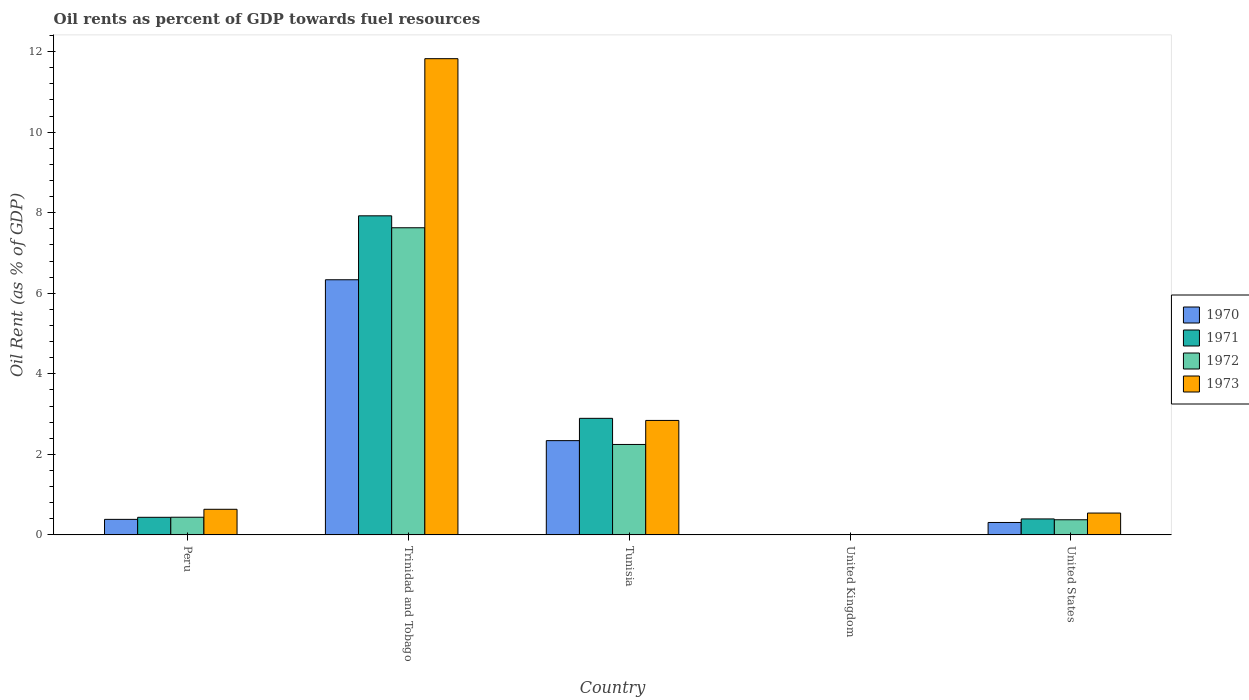Are the number of bars on each tick of the X-axis equal?
Keep it short and to the point. Yes. How many bars are there on the 5th tick from the left?
Your answer should be compact. 4. What is the label of the 5th group of bars from the left?
Give a very brief answer. United States. In how many cases, is the number of bars for a given country not equal to the number of legend labels?
Provide a succinct answer. 0. What is the oil rent in 1972 in Peru?
Provide a short and direct response. 0.44. Across all countries, what is the maximum oil rent in 1971?
Your answer should be compact. 7.92. Across all countries, what is the minimum oil rent in 1973?
Provide a short and direct response. 0. In which country was the oil rent in 1973 maximum?
Ensure brevity in your answer.  Trinidad and Tobago. In which country was the oil rent in 1972 minimum?
Make the answer very short. United Kingdom. What is the total oil rent in 1970 in the graph?
Offer a terse response. 9.37. What is the difference between the oil rent in 1970 in Peru and that in United Kingdom?
Provide a succinct answer. 0.38. What is the difference between the oil rent in 1972 in United Kingdom and the oil rent in 1973 in Peru?
Keep it short and to the point. -0.63. What is the average oil rent in 1970 per country?
Ensure brevity in your answer.  1.87. What is the difference between the oil rent of/in 1971 and oil rent of/in 1972 in United States?
Your response must be concise. 0.02. In how many countries, is the oil rent in 1970 greater than 6.8 %?
Ensure brevity in your answer.  0. What is the ratio of the oil rent in 1970 in Tunisia to that in United States?
Give a very brief answer. 7.59. Is the difference between the oil rent in 1971 in Trinidad and Tobago and Tunisia greater than the difference between the oil rent in 1972 in Trinidad and Tobago and Tunisia?
Ensure brevity in your answer.  No. What is the difference between the highest and the second highest oil rent in 1970?
Your answer should be compact. -1.95. What is the difference between the highest and the lowest oil rent in 1972?
Your response must be concise. 7.62. What does the 4th bar from the right in Trinidad and Tobago represents?
Give a very brief answer. 1970. How many bars are there?
Provide a succinct answer. 20. What is the difference between two consecutive major ticks on the Y-axis?
Your answer should be compact. 2. What is the title of the graph?
Give a very brief answer. Oil rents as percent of GDP towards fuel resources. What is the label or title of the X-axis?
Ensure brevity in your answer.  Country. What is the label or title of the Y-axis?
Your response must be concise. Oil Rent (as % of GDP). What is the Oil Rent (as % of GDP) of 1970 in Peru?
Offer a terse response. 0.39. What is the Oil Rent (as % of GDP) in 1971 in Peru?
Ensure brevity in your answer.  0.44. What is the Oil Rent (as % of GDP) in 1972 in Peru?
Keep it short and to the point. 0.44. What is the Oil Rent (as % of GDP) of 1973 in Peru?
Provide a short and direct response. 0.64. What is the Oil Rent (as % of GDP) of 1970 in Trinidad and Tobago?
Ensure brevity in your answer.  6.33. What is the Oil Rent (as % of GDP) in 1971 in Trinidad and Tobago?
Your response must be concise. 7.92. What is the Oil Rent (as % of GDP) of 1972 in Trinidad and Tobago?
Offer a terse response. 7.63. What is the Oil Rent (as % of GDP) of 1973 in Trinidad and Tobago?
Keep it short and to the point. 11.82. What is the Oil Rent (as % of GDP) in 1970 in Tunisia?
Provide a short and direct response. 2.34. What is the Oil Rent (as % of GDP) in 1971 in Tunisia?
Provide a succinct answer. 2.89. What is the Oil Rent (as % of GDP) in 1972 in Tunisia?
Give a very brief answer. 2.25. What is the Oil Rent (as % of GDP) in 1973 in Tunisia?
Keep it short and to the point. 2.84. What is the Oil Rent (as % of GDP) of 1970 in United Kingdom?
Offer a terse response. 0. What is the Oil Rent (as % of GDP) in 1971 in United Kingdom?
Your answer should be compact. 0. What is the Oil Rent (as % of GDP) of 1972 in United Kingdom?
Your response must be concise. 0. What is the Oil Rent (as % of GDP) in 1973 in United Kingdom?
Offer a terse response. 0. What is the Oil Rent (as % of GDP) of 1970 in United States?
Your answer should be compact. 0.31. What is the Oil Rent (as % of GDP) in 1971 in United States?
Your answer should be compact. 0.4. What is the Oil Rent (as % of GDP) in 1972 in United States?
Your answer should be compact. 0.38. What is the Oil Rent (as % of GDP) of 1973 in United States?
Give a very brief answer. 0.54. Across all countries, what is the maximum Oil Rent (as % of GDP) in 1970?
Your answer should be compact. 6.33. Across all countries, what is the maximum Oil Rent (as % of GDP) of 1971?
Offer a terse response. 7.92. Across all countries, what is the maximum Oil Rent (as % of GDP) in 1972?
Keep it short and to the point. 7.63. Across all countries, what is the maximum Oil Rent (as % of GDP) in 1973?
Make the answer very short. 11.82. Across all countries, what is the minimum Oil Rent (as % of GDP) in 1970?
Make the answer very short. 0. Across all countries, what is the minimum Oil Rent (as % of GDP) in 1971?
Offer a very short reply. 0. Across all countries, what is the minimum Oil Rent (as % of GDP) in 1972?
Your answer should be compact. 0. Across all countries, what is the minimum Oil Rent (as % of GDP) in 1973?
Provide a short and direct response. 0. What is the total Oil Rent (as % of GDP) in 1970 in the graph?
Make the answer very short. 9.37. What is the total Oil Rent (as % of GDP) in 1971 in the graph?
Offer a very short reply. 11.65. What is the total Oil Rent (as % of GDP) of 1972 in the graph?
Offer a very short reply. 10.69. What is the total Oil Rent (as % of GDP) of 1973 in the graph?
Offer a terse response. 15.85. What is the difference between the Oil Rent (as % of GDP) of 1970 in Peru and that in Trinidad and Tobago?
Your response must be concise. -5.95. What is the difference between the Oil Rent (as % of GDP) of 1971 in Peru and that in Trinidad and Tobago?
Your response must be concise. -7.49. What is the difference between the Oil Rent (as % of GDP) in 1972 in Peru and that in Trinidad and Tobago?
Your answer should be very brief. -7.19. What is the difference between the Oil Rent (as % of GDP) of 1973 in Peru and that in Trinidad and Tobago?
Ensure brevity in your answer.  -11.19. What is the difference between the Oil Rent (as % of GDP) in 1970 in Peru and that in Tunisia?
Ensure brevity in your answer.  -1.95. What is the difference between the Oil Rent (as % of GDP) in 1971 in Peru and that in Tunisia?
Keep it short and to the point. -2.46. What is the difference between the Oil Rent (as % of GDP) in 1972 in Peru and that in Tunisia?
Give a very brief answer. -1.81. What is the difference between the Oil Rent (as % of GDP) of 1973 in Peru and that in Tunisia?
Offer a very short reply. -2.21. What is the difference between the Oil Rent (as % of GDP) of 1970 in Peru and that in United Kingdom?
Provide a short and direct response. 0.38. What is the difference between the Oil Rent (as % of GDP) of 1971 in Peru and that in United Kingdom?
Offer a terse response. 0.44. What is the difference between the Oil Rent (as % of GDP) of 1972 in Peru and that in United Kingdom?
Ensure brevity in your answer.  0.44. What is the difference between the Oil Rent (as % of GDP) of 1973 in Peru and that in United Kingdom?
Make the answer very short. 0.63. What is the difference between the Oil Rent (as % of GDP) in 1970 in Peru and that in United States?
Your answer should be very brief. 0.08. What is the difference between the Oil Rent (as % of GDP) in 1971 in Peru and that in United States?
Ensure brevity in your answer.  0.04. What is the difference between the Oil Rent (as % of GDP) of 1972 in Peru and that in United States?
Offer a terse response. 0.06. What is the difference between the Oil Rent (as % of GDP) in 1973 in Peru and that in United States?
Provide a succinct answer. 0.09. What is the difference between the Oil Rent (as % of GDP) in 1970 in Trinidad and Tobago and that in Tunisia?
Provide a succinct answer. 3.99. What is the difference between the Oil Rent (as % of GDP) in 1971 in Trinidad and Tobago and that in Tunisia?
Ensure brevity in your answer.  5.03. What is the difference between the Oil Rent (as % of GDP) in 1972 in Trinidad and Tobago and that in Tunisia?
Your response must be concise. 5.38. What is the difference between the Oil Rent (as % of GDP) in 1973 in Trinidad and Tobago and that in Tunisia?
Make the answer very short. 8.98. What is the difference between the Oil Rent (as % of GDP) of 1970 in Trinidad and Tobago and that in United Kingdom?
Your answer should be compact. 6.33. What is the difference between the Oil Rent (as % of GDP) of 1971 in Trinidad and Tobago and that in United Kingdom?
Provide a short and direct response. 7.92. What is the difference between the Oil Rent (as % of GDP) in 1972 in Trinidad and Tobago and that in United Kingdom?
Your answer should be compact. 7.62. What is the difference between the Oil Rent (as % of GDP) in 1973 in Trinidad and Tobago and that in United Kingdom?
Offer a terse response. 11.82. What is the difference between the Oil Rent (as % of GDP) in 1970 in Trinidad and Tobago and that in United States?
Offer a terse response. 6.03. What is the difference between the Oil Rent (as % of GDP) in 1971 in Trinidad and Tobago and that in United States?
Provide a short and direct response. 7.53. What is the difference between the Oil Rent (as % of GDP) in 1972 in Trinidad and Tobago and that in United States?
Make the answer very short. 7.25. What is the difference between the Oil Rent (as % of GDP) in 1973 in Trinidad and Tobago and that in United States?
Provide a short and direct response. 11.28. What is the difference between the Oil Rent (as % of GDP) in 1970 in Tunisia and that in United Kingdom?
Your answer should be very brief. 2.34. What is the difference between the Oil Rent (as % of GDP) in 1971 in Tunisia and that in United Kingdom?
Keep it short and to the point. 2.89. What is the difference between the Oil Rent (as % of GDP) of 1972 in Tunisia and that in United Kingdom?
Provide a short and direct response. 2.24. What is the difference between the Oil Rent (as % of GDP) of 1973 in Tunisia and that in United Kingdom?
Your response must be concise. 2.84. What is the difference between the Oil Rent (as % of GDP) of 1970 in Tunisia and that in United States?
Your answer should be very brief. 2.03. What is the difference between the Oil Rent (as % of GDP) in 1971 in Tunisia and that in United States?
Provide a short and direct response. 2.5. What is the difference between the Oil Rent (as % of GDP) of 1972 in Tunisia and that in United States?
Offer a terse response. 1.87. What is the difference between the Oil Rent (as % of GDP) of 1973 in Tunisia and that in United States?
Your response must be concise. 2.3. What is the difference between the Oil Rent (as % of GDP) in 1970 in United Kingdom and that in United States?
Ensure brevity in your answer.  -0.31. What is the difference between the Oil Rent (as % of GDP) of 1971 in United Kingdom and that in United States?
Your answer should be compact. -0.4. What is the difference between the Oil Rent (as % of GDP) in 1972 in United Kingdom and that in United States?
Keep it short and to the point. -0.37. What is the difference between the Oil Rent (as % of GDP) in 1973 in United Kingdom and that in United States?
Provide a succinct answer. -0.54. What is the difference between the Oil Rent (as % of GDP) of 1970 in Peru and the Oil Rent (as % of GDP) of 1971 in Trinidad and Tobago?
Your answer should be compact. -7.54. What is the difference between the Oil Rent (as % of GDP) of 1970 in Peru and the Oil Rent (as % of GDP) of 1972 in Trinidad and Tobago?
Provide a short and direct response. -7.24. What is the difference between the Oil Rent (as % of GDP) in 1970 in Peru and the Oil Rent (as % of GDP) in 1973 in Trinidad and Tobago?
Offer a very short reply. -11.44. What is the difference between the Oil Rent (as % of GDP) of 1971 in Peru and the Oil Rent (as % of GDP) of 1972 in Trinidad and Tobago?
Offer a terse response. -7.19. What is the difference between the Oil Rent (as % of GDP) of 1971 in Peru and the Oil Rent (as % of GDP) of 1973 in Trinidad and Tobago?
Provide a short and direct response. -11.39. What is the difference between the Oil Rent (as % of GDP) in 1972 in Peru and the Oil Rent (as % of GDP) in 1973 in Trinidad and Tobago?
Provide a short and direct response. -11.38. What is the difference between the Oil Rent (as % of GDP) in 1970 in Peru and the Oil Rent (as % of GDP) in 1971 in Tunisia?
Your response must be concise. -2.51. What is the difference between the Oil Rent (as % of GDP) of 1970 in Peru and the Oil Rent (as % of GDP) of 1972 in Tunisia?
Keep it short and to the point. -1.86. What is the difference between the Oil Rent (as % of GDP) of 1970 in Peru and the Oil Rent (as % of GDP) of 1973 in Tunisia?
Offer a very short reply. -2.46. What is the difference between the Oil Rent (as % of GDP) of 1971 in Peru and the Oil Rent (as % of GDP) of 1972 in Tunisia?
Offer a very short reply. -1.81. What is the difference between the Oil Rent (as % of GDP) of 1971 in Peru and the Oil Rent (as % of GDP) of 1973 in Tunisia?
Offer a terse response. -2.4. What is the difference between the Oil Rent (as % of GDP) of 1972 in Peru and the Oil Rent (as % of GDP) of 1973 in Tunisia?
Your response must be concise. -2.4. What is the difference between the Oil Rent (as % of GDP) of 1970 in Peru and the Oil Rent (as % of GDP) of 1971 in United Kingdom?
Keep it short and to the point. 0.38. What is the difference between the Oil Rent (as % of GDP) in 1970 in Peru and the Oil Rent (as % of GDP) in 1972 in United Kingdom?
Your answer should be very brief. 0.38. What is the difference between the Oil Rent (as % of GDP) in 1970 in Peru and the Oil Rent (as % of GDP) in 1973 in United Kingdom?
Provide a succinct answer. 0.38. What is the difference between the Oil Rent (as % of GDP) in 1971 in Peru and the Oil Rent (as % of GDP) in 1972 in United Kingdom?
Your answer should be very brief. 0.44. What is the difference between the Oil Rent (as % of GDP) of 1971 in Peru and the Oil Rent (as % of GDP) of 1973 in United Kingdom?
Offer a very short reply. 0.43. What is the difference between the Oil Rent (as % of GDP) of 1972 in Peru and the Oil Rent (as % of GDP) of 1973 in United Kingdom?
Keep it short and to the point. 0.44. What is the difference between the Oil Rent (as % of GDP) of 1970 in Peru and the Oil Rent (as % of GDP) of 1971 in United States?
Make the answer very short. -0.01. What is the difference between the Oil Rent (as % of GDP) in 1970 in Peru and the Oil Rent (as % of GDP) in 1972 in United States?
Provide a short and direct response. 0.01. What is the difference between the Oil Rent (as % of GDP) in 1970 in Peru and the Oil Rent (as % of GDP) in 1973 in United States?
Offer a very short reply. -0.16. What is the difference between the Oil Rent (as % of GDP) in 1971 in Peru and the Oil Rent (as % of GDP) in 1972 in United States?
Provide a short and direct response. 0.06. What is the difference between the Oil Rent (as % of GDP) in 1971 in Peru and the Oil Rent (as % of GDP) in 1973 in United States?
Offer a very short reply. -0.11. What is the difference between the Oil Rent (as % of GDP) of 1972 in Peru and the Oil Rent (as % of GDP) of 1973 in United States?
Give a very brief answer. -0.1. What is the difference between the Oil Rent (as % of GDP) in 1970 in Trinidad and Tobago and the Oil Rent (as % of GDP) in 1971 in Tunisia?
Your answer should be compact. 3.44. What is the difference between the Oil Rent (as % of GDP) of 1970 in Trinidad and Tobago and the Oil Rent (as % of GDP) of 1972 in Tunisia?
Your response must be concise. 4.09. What is the difference between the Oil Rent (as % of GDP) in 1970 in Trinidad and Tobago and the Oil Rent (as % of GDP) in 1973 in Tunisia?
Your answer should be compact. 3.49. What is the difference between the Oil Rent (as % of GDP) of 1971 in Trinidad and Tobago and the Oil Rent (as % of GDP) of 1972 in Tunisia?
Give a very brief answer. 5.68. What is the difference between the Oil Rent (as % of GDP) of 1971 in Trinidad and Tobago and the Oil Rent (as % of GDP) of 1973 in Tunisia?
Provide a short and direct response. 5.08. What is the difference between the Oil Rent (as % of GDP) of 1972 in Trinidad and Tobago and the Oil Rent (as % of GDP) of 1973 in Tunisia?
Give a very brief answer. 4.78. What is the difference between the Oil Rent (as % of GDP) of 1970 in Trinidad and Tobago and the Oil Rent (as % of GDP) of 1971 in United Kingdom?
Your answer should be compact. 6.33. What is the difference between the Oil Rent (as % of GDP) in 1970 in Trinidad and Tobago and the Oil Rent (as % of GDP) in 1972 in United Kingdom?
Give a very brief answer. 6.33. What is the difference between the Oil Rent (as % of GDP) of 1970 in Trinidad and Tobago and the Oil Rent (as % of GDP) of 1973 in United Kingdom?
Offer a terse response. 6.33. What is the difference between the Oil Rent (as % of GDP) of 1971 in Trinidad and Tobago and the Oil Rent (as % of GDP) of 1972 in United Kingdom?
Make the answer very short. 7.92. What is the difference between the Oil Rent (as % of GDP) in 1971 in Trinidad and Tobago and the Oil Rent (as % of GDP) in 1973 in United Kingdom?
Provide a short and direct response. 7.92. What is the difference between the Oil Rent (as % of GDP) in 1972 in Trinidad and Tobago and the Oil Rent (as % of GDP) in 1973 in United Kingdom?
Provide a short and direct response. 7.62. What is the difference between the Oil Rent (as % of GDP) in 1970 in Trinidad and Tobago and the Oil Rent (as % of GDP) in 1971 in United States?
Make the answer very short. 5.94. What is the difference between the Oil Rent (as % of GDP) in 1970 in Trinidad and Tobago and the Oil Rent (as % of GDP) in 1972 in United States?
Offer a very short reply. 5.96. What is the difference between the Oil Rent (as % of GDP) of 1970 in Trinidad and Tobago and the Oil Rent (as % of GDP) of 1973 in United States?
Your response must be concise. 5.79. What is the difference between the Oil Rent (as % of GDP) of 1971 in Trinidad and Tobago and the Oil Rent (as % of GDP) of 1972 in United States?
Make the answer very short. 7.55. What is the difference between the Oil Rent (as % of GDP) of 1971 in Trinidad and Tobago and the Oil Rent (as % of GDP) of 1973 in United States?
Your response must be concise. 7.38. What is the difference between the Oil Rent (as % of GDP) in 1972 in Trinidad and Tobago and the Oil Rent (as % of GDP) in 1973 in United States?
Give a very brief answer. 7.08. What is the difference between the Oil Rent (as % of GDP) in 1970 in Tunisia and the Oil Rent (as % of GDP) in 1971 in United Kingdom?
Give a very brief answer. 2.34. What is the difference between the Oil Rent (as % of GDP) of 1970 in Tunisia and the Oil Rent (as % of GDP) of 1972 in United Kingdom?
Your answer should be very brief. 2.34. What is the difference between the Oil Rent (as % of GDP) in 1970 in Tunisia and the Oil Rent (as % of GDP) in 1973 in United Kingdom?
Provide a short and direct response. 2.34. What is the difference between the Oil Rent (as % of GDP) in 1971 in Tunisia and the Oil Rent (as % of GDP) in 1972 in United Kingdom?
Make the answer very short. 2.89. What is the difference between the Oil Rent (as % of GDP) in 1971 in Tunisia and the Oil Rent (as % of GDP) in 1973 in United Kingdom?
Your answer should be compact. 2.89. What is the difference between the Oil Rent (as % of GDP) of 1972 in Tunisia and the Oil Rent (as % of GDP) of 1973 in United Kingdom?
Give a very brief answer. 2.24. What is the difference between the Oil Rent (as % of GDP) of 1970 in Tunisia and the Oil Rent (as % of GDP) of 1971 in United States?
Your answer should be compact. 1.94. What is the difference between the Oil Rent (as % of GDP) of 1970 in Tunisia and the Oil Rent (as % of GDP) of 1972 in United States?
Your response must be concise. 1.96. What is the difference between the Oil Rent (as % of GDP) of 1970 in Tunisia and the Oil Rent (as % of GDP) of 1973 in United States?
Provide a succinct answer. 1.8. What is the difference between the Oil Rent (as % of GDP) in 1971 in Tunisia and the Oil Rent (as % of GDP) in 1972 in United States?
Your response must be concise. 2.52. What is the difference between the Oil Rent (as % of GDP) in 1971 in Tunisia and the Oil Rent (as % of GDP) in 1973 in United States?
Offer a terse response. 2.35. What is the difference between the Oil Rent (as % of GDP) in 1972 in Tunisia and the Oil Rent (as % of GDP) in 1973 in United States?
Make the answer very short. 1.7. What is the difference between the Oil Rent (as % of GDP) in 1970 in United Kingdom and the Oil Rent (as % of GDP) in 1971 in United States?
Keep it short and to the point. -0.4. What is the difference between the Oil Rent (as % of GDP) in 1970 in United Kingdom and the Oil Rent (as % of GDP) in 1972 in United States?
Give a very brief answer. -0.38. What is the difference between the Oil Rent (as % of GDP) of 1970 in United Kingdom and the Oil Rent (as % of GDP) of 1973 in United States?
Your answer should be compact. -0.54. What is the difference between the Oil Rent (as % of GDP) in 1971 in United Kingdom and the Oil Rent (as % of GDP) in 1972 in United States?
Your answer should be very brief. -0.38. What is the difference between the Oil Rent (as % of GDP) of 1971 in United Kingdom and the Oil Rent (as % of GDP) of 1973 in United States?
Provide a succinct answer. -0.54. What is the difference between the Oil Rent (as % of GDP) in 1972 in United Kingdom and the Oil Rent (as % of GDP) in 1973 in United States?
Ensure brevity in your answer.  -0.54. What is the average Oil Rent (as % of GDP) in 1970 per country?
Offer a very short reply. 1.87. What is the average Oil Rent (as % of GDP) in 1971 per country?
Offer a very short reply. 2.33. What is the average Oil Rent (as % of GDP) in 1972 per country?
Offer a terse response. 2.14. What is the average Oil Rent (as % of GDP) in 1973 per country?
Your response must be concise. 3.17. What is the difference between the Oil Rent (as % of GDP) in 1970 and Oil Rent (as % of GDP) in 1971 in Peru?
Offer a very short reply. -0.05. What is the difference between the Oil Rent (as % of GDP) in 1970 and Oil Rent (as % of GDP) in 1972 in Peru?
Offer a terse response. -0.05. What is the difference between the Oil Rent (as % of GDP) of 1970 and Oil Rent (as % of GDP) of 1973 in Peru?
Make the answer very short. -0.25. What is the difference between the Oil Rent (as % of GDP) in 1971 and Oil Rent (as % of GDP) in 1972 in Peru?
Your answer should be compact. -0. What is the difference between the Oil Rent (as % of GDP) in 1971 and Oil Rent (as % of GDP) in 1973 in Peru?
Offer a terse response. -0.2. What is the difference between the Oil Rent (as % of GDP) of 1972 and Oil Rent (as % of GDP) of 1973 in Peru?
Give a very brief answer. -0.2. What is the difference between the Oil Rent (as % of GDP) in 1970 and Oil Rent (as % of GDP) in 1971 in Trinidad and Tobago?
Your response must be concise. -1.59. What is the difference between the Oil Rent (as % of GDP) in 1970 and Oil Rent (as % of GDP) in 1972 in Trinidad and Tobago?
Your response must be concise. -1.29. What is the difference between the Oil Rent (as % of GDP) of 1970 and Oil Rent (as % of GDP) of 1973 in Trinidad and Tobago?
Your response must be concise. -5.49. What is the difference between the Oil Rent (as % of GDP) in 1971 and Oil Rent (as % of GDP) in 1972 in Trinidad and Tobago?
Make the answer very short. 0.3. What is the difference between the Oil Rent (as % of GDP) in 1971 and Oil Rent (as % of GDP) in 1973 in Trinidad and Tobago?
Offer a terse response. -3.9. What is the difference between the Oil Rent (as % of GDP) of 1972 and Oil Rent (as % of GDP) of 1973 in Trinidad and Tobago?
Offer a very short reply. -4.2. What is the difference between the Oil Rent (as % of GDP) in 1970 and Oil Rent (as % of GDP) in 1971 in Tunisia?
Give a very brief answer. -0.55. What is the difference between the Oil Rent (as % of GDP) of 1970 and Oil Rent (as % of GDP) of 1972 in Tunisia?
Your answer should be compact. 0.1. What is the difference between the Oil Rent (as % of GDP) in 1970 and Oil Rent (as % of GDP) in 1973 in Tunisia?
Provide a short and direct response. -0.5. What is the difference between the Oil Rent (as % of GDP) of 1971 and Oil Rent (as % of GDP) of 1972 in Tunisia?
Your answer should be compact. 0.65. What is the difference between the Oil Rent (as % of GDP) of 1971 and Oil Rent (as % of GDP) of 1973 in Tunisia?
Ensure brevity in your answer.  0.05. What is the difference between the Oil Rent (as % of GDP) of 1972 and Oil Rent (as % of GDP) of 1973 in Tunisia?
Your answer should be very brief. -0.6. What is the difference between the Oil Rent (as % of GDP) in 1970 and Oil Rent (as % of GDP) in 1972 in United Kingdom?
Ensure brevity in your answer.  -0. What is the difference between the Oil Rent (as % of GDP) of 1970 and Oil Rent (as % of GDP) of 1973 in United Kingdom?
Ensure brevity in your answer.  -0. What is the difference between the Oil Rent (as % of GDP) of 1971 and Oil Rent (as % of GDP) of 1972 in United Kingdom?
Ensure brevity in your answer.  -0. What is the difference between the Oil Rent (as % of GDP) of 1971 and Oil Rent (as % of GDP) of 1973 in United Kingdom?
Your answer should be very brief. -0. What is the difference between the Oil Rent (as % of GDP) in 1972 and Oil Rent (as % of GDP) in 1973 in United Kingdom?
Offer a terse response. -0. What is the difference between the Oil Rent (as % of GDP) in 1970 and Oil Rent (as % of GDP) in 1971 in United States?
Give a very brief answer. -0.09. What is the difference between the Oil Rent (as % of GDP) of 1970 and Oil Rent (as % of GDP) of 1972 in United States?
Offer a very short reply. -0.07. What is the difference between the Oil Rent (as % of GDP) in 1970 and Oil Rent (as % of GDP) in 1973 in United States?
Ensure brevity in your answer.  -0.23. What is the difference between the Oil Rent (as % of GDP) in 1971 and Oil Rent (as % of GDP) in 1972 in United States?
Your response must be concise. 0.02. What is the difference between the Oil Rent (as % of GDP) in 1971 and Oil Rent (as % of GDP) in 1973 in United States?
Your response must be concise. -0.15. What is the difference between the Oil Rent (as % of GDP) of 1972 and Oil Rent (as % of GDP) of 1973 in United States?
Give a very brief answer. -0.17. What is the ratio of the Oil Rent (as % of GDP) of 1970 in Peru to that in Trinidad and Tobago?
Offer a very short reply. 0.06. What is the ratio of the Oil Rent (as % of GDP) in 1971 in Peru to that in Trinidad and Tobago?
Provide a succinct answer. 0.06. What is the ratio of the Oil Rent (as % of GDP) in 1972 in Peru to that in Trinidad and Tobago?
Keep it short and to the point. 0.06. What is the ratio of the Oil Rent (as % of GDP) of 1973 in Peru to that in Trinidad and Tobago?
Make the answer very short. 0.05. What is the ratio of the Oil Rent (as % of GDP) of 1970 in Peru to that in Tunisia?
Offer a very short reply. 0.16. What is the ratio of the Oil Rent (as % of GDP) of 1971 in Peru to that in Tunisia?
Make the answer very short. 0.15. What is the ratio of the Oil Rent (as % of GDP) of 1972 in Peru to that in Tunisia?
Your answer should be very brief. 0.2. What is the ratio of the Oil Rent (as % of GDP) in 1973 in Peru to that in Tunisia?
Make the answer very short. 0.22. What is the ratio of the Oil Rent (as % of GDP) of 1970 in Peru to that in United Kingdom?
Offer a terse response. 435.22. What is the ratio of the Oil Rent (as % of GDP) in 1971 in Peru to that in United Kingdom?
Give a very brief answer. 617.08. What is the ratio of the Oil Rent (as % of GDP) of 1972 in Peru to that in United Kingdom?
Your answer should be very brief. 339.21. What is the ratio of the Oil Rent (as % of GDP) in 1973 in Peru to that in United Kingdom?
Your answer should be very brief. 283.34. What is the ratio of the Oil Rent (as % of GDP) in 1970 in Peru to that in United States?
Offer a terse response. 1.25. What is the ratio of the Oil Rent (as % of GDP) in 1971 in Peru to that in United States?
Give a very brief answer. 1.1. What is the ratio of the Oil Rent (as % of GDP) in 1972 in Peru to that in United States?
Your answer should be compact. 1.17. What is the ratio of the Oil Rent (as % of GDP) of 1973 in Peru to that in United States?
Offer a terse response. 1.17. What is the ratio of the Oil Rent (as % of GDP) of 1970 in Trinidad and Tobago to that in Tunisia?
Provide a short and direct response. 2.71. What is the ratio of the Oil Rent (as % of GDP) in 1971 in Trinidad and Tobago to that in Tunisia?
Make the answer very short. 2.74. What is the ratio of the Oil Rent (as % of GDP) in 1972 in Trinidad and Tobago to that in Tunisia?
Provide a short and direct response. 3.4. What is the ratio of the Oil Rent (as % of GDP) in 1973 in Trinidad and Tobago to that in Tunisia?
Keep it short and to the point. 4.16. What is the ratio of the Oil Rent (as % of GDP) of 1970 in Trinidad and Tobago to that in United Kingdom?
Offer a terse response. 7151.98. What is the ratio of the Oil Rent (as % of GDP) in 1971 in Trinidad and Tobago to that in United Kingdom?
Your answer should be compact. 1.12e+04. What is the ratio of the Oil Rent (as % of GDP) of 1972 in Trinidad and Tobago to that in United Kingdom?
Ensure brevity in your answer.  5894.4. What is the ratio of the Oil Rent (as % of GDP) in 1973 in Trinidad and Tobago to that in United Kingdom?
Offer a very short reply. 5268.85. What is the ratio of the Oil Rent (as % of GDP) in 1970 in Trinidad and Tobago to that in United States?
Provide a succinct answer. 20.53. What is the ratio of the Oil Rent (as % of GDP) of 1971 in Trinidad and Tobago to that in United States?
Your answer should be very brief. 19.98. What is the ratio of the Oil Rent (as % of GDP) of 1972 in Trinidad and Tobago to that in United States?
Your response must be concise. 20.29. What is the ratio of the Oil Rent (as % of GDP) in 1973 in Trinidad and Tobago to that in United States?
Keep it short and to the point. 21.8. What is the ratio of the Oil Rent (as % of GDP) in 1970 in Tunisia to that in United Kingdom?
Make the answer very short. 2642.42. What is the ratio of the Oil Rent (as % of GDP) in 1971 in Tunisia to that in United Kingdom?
Keep it short and to the point. 4088.61. What is the ratio of the Oil Rent (as % of GDP) of 1972 in Tunisia to that in United Kingdom?
Ensure brevity in your answer.  1735.44. What is the ratio of the Oil Rent (as % of GDP) of 1973 in Tunisia to that in United Kingdom?
Ensure brevity in your answer.  1266.39. What is the ratio of the Oil Rent (as % of GDP) in 1970 in Tunisia to that in United States?
Provide a short and direct response. 7.59. What is the ratio of the Oil Rent (as % of GDP) of 1971 in Tunisia to that in United States?
Your response must be concise. 7.3. What is the ratio of the Oil Rent (as % of GDP) of 1972 in Tunisia to that in United States?
Your answer should be very brief. 5.97. What is the ratio of the Oil Rent (as % of GDP) of 1973 in Tunisia to that in United States?
Provide a short and direct response. 5.24. What is the ratio of the Oil Rent (as % of GDP) of 1970 in United Kingdom to that in United States?
Offer a very short reply. 0. What is the ratio of the Oil Rent (as % of GDP) of 1971 in United Kingdom to that in United States?
Provide a succinct answer. 0. What is the ratio of the Oil Rent (as % of GDP) in 1972 in United Kingdom to that in United States?
Ensure brevity in your answer.  0. What is the ratio of the Oil Rent (as % of GDP) of 1973 in United Kingdom to that in United States?
Your answer should be very brief. 0. What is the difference between the highest and the second highest Oil Rent (as % of GDP) in 1970?
Provide a short and direct response. 3.99. What is the difference between the highest and the second highest Oil Rent (as % of GDP) of 1971?
Give a very brief answer. 5.03. What is the difference between the highest and the second highest Oil Rent (as % of GDP) of 1972?
Provide a short and direct response. 5.38. What is the difference between the highest and the second highest Oil Rent (as % of GDP) of 1973?
Ensure brevity in your answer.  8.98. What is the difference between the highest and the lowest Oil Rent (as % of GDP) of 1970?
Your response must be concise. 6.33. What is the difference between the highest and the lowest Oil Rent (as % of GDP) of 1971?
Ensure brevity in your answer.  7.92. What is the difference between the highest and the lowest Oil Rent (as % of GDP) of 1972?
Give a very brief answer. 7.62. What is the difference between the highest and the lowest Oil Rent (as % of GDP) of 1973?
Your answer should be very brief. 11.82. 